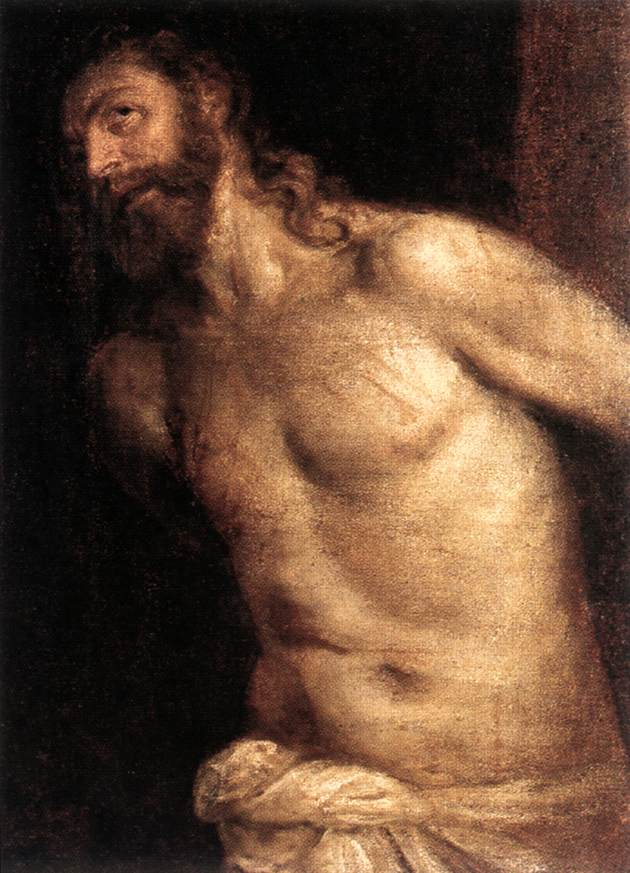What could be a short, realistic scenario for this scene in the image? In a dimly lit room of an ancient temple, a devout man meditates silently. His bare, muscular torso reflects years of hardship and devotion. Draped in a simple white cloth, he stands as a symbol of suffering and faith, his figure illuminated by a single ray of sunlight breaking through a small window high above.  Can you describe a more detailed, realistic scenario for this scene? In a secluded, crumbling temple on the outskirts of a decaying city, twilight casts long shadows across the stone floor. The air is thick with the scent of incense and ancient dust. Amidst the dim glow of flickering candles, a statue-like figure stands against the darkness. His face, etched with lines of pain and wisdom, is partially hidden by a tangle of beard and hair, both darkened with dirt and sweat. A harsh life etched into his taut, scarred skin reveals tales of battles, pilgrimages, and fasting. Draped in a simple, worn white cloth that barely reaches his knees, he emanates a mix of strength and vulnerability. His arms are bound behind him, tethered to a battered wooden post, suggesting imprisonment or ritual. A beam of ethereal light pierces through a crack in the ancient stone walls, illuminating his suffering body like a divine spotlight against the oppressive gloom, evoking a powerful narrative of sacrifice, faith, and the relentless pursuit of redemption. 